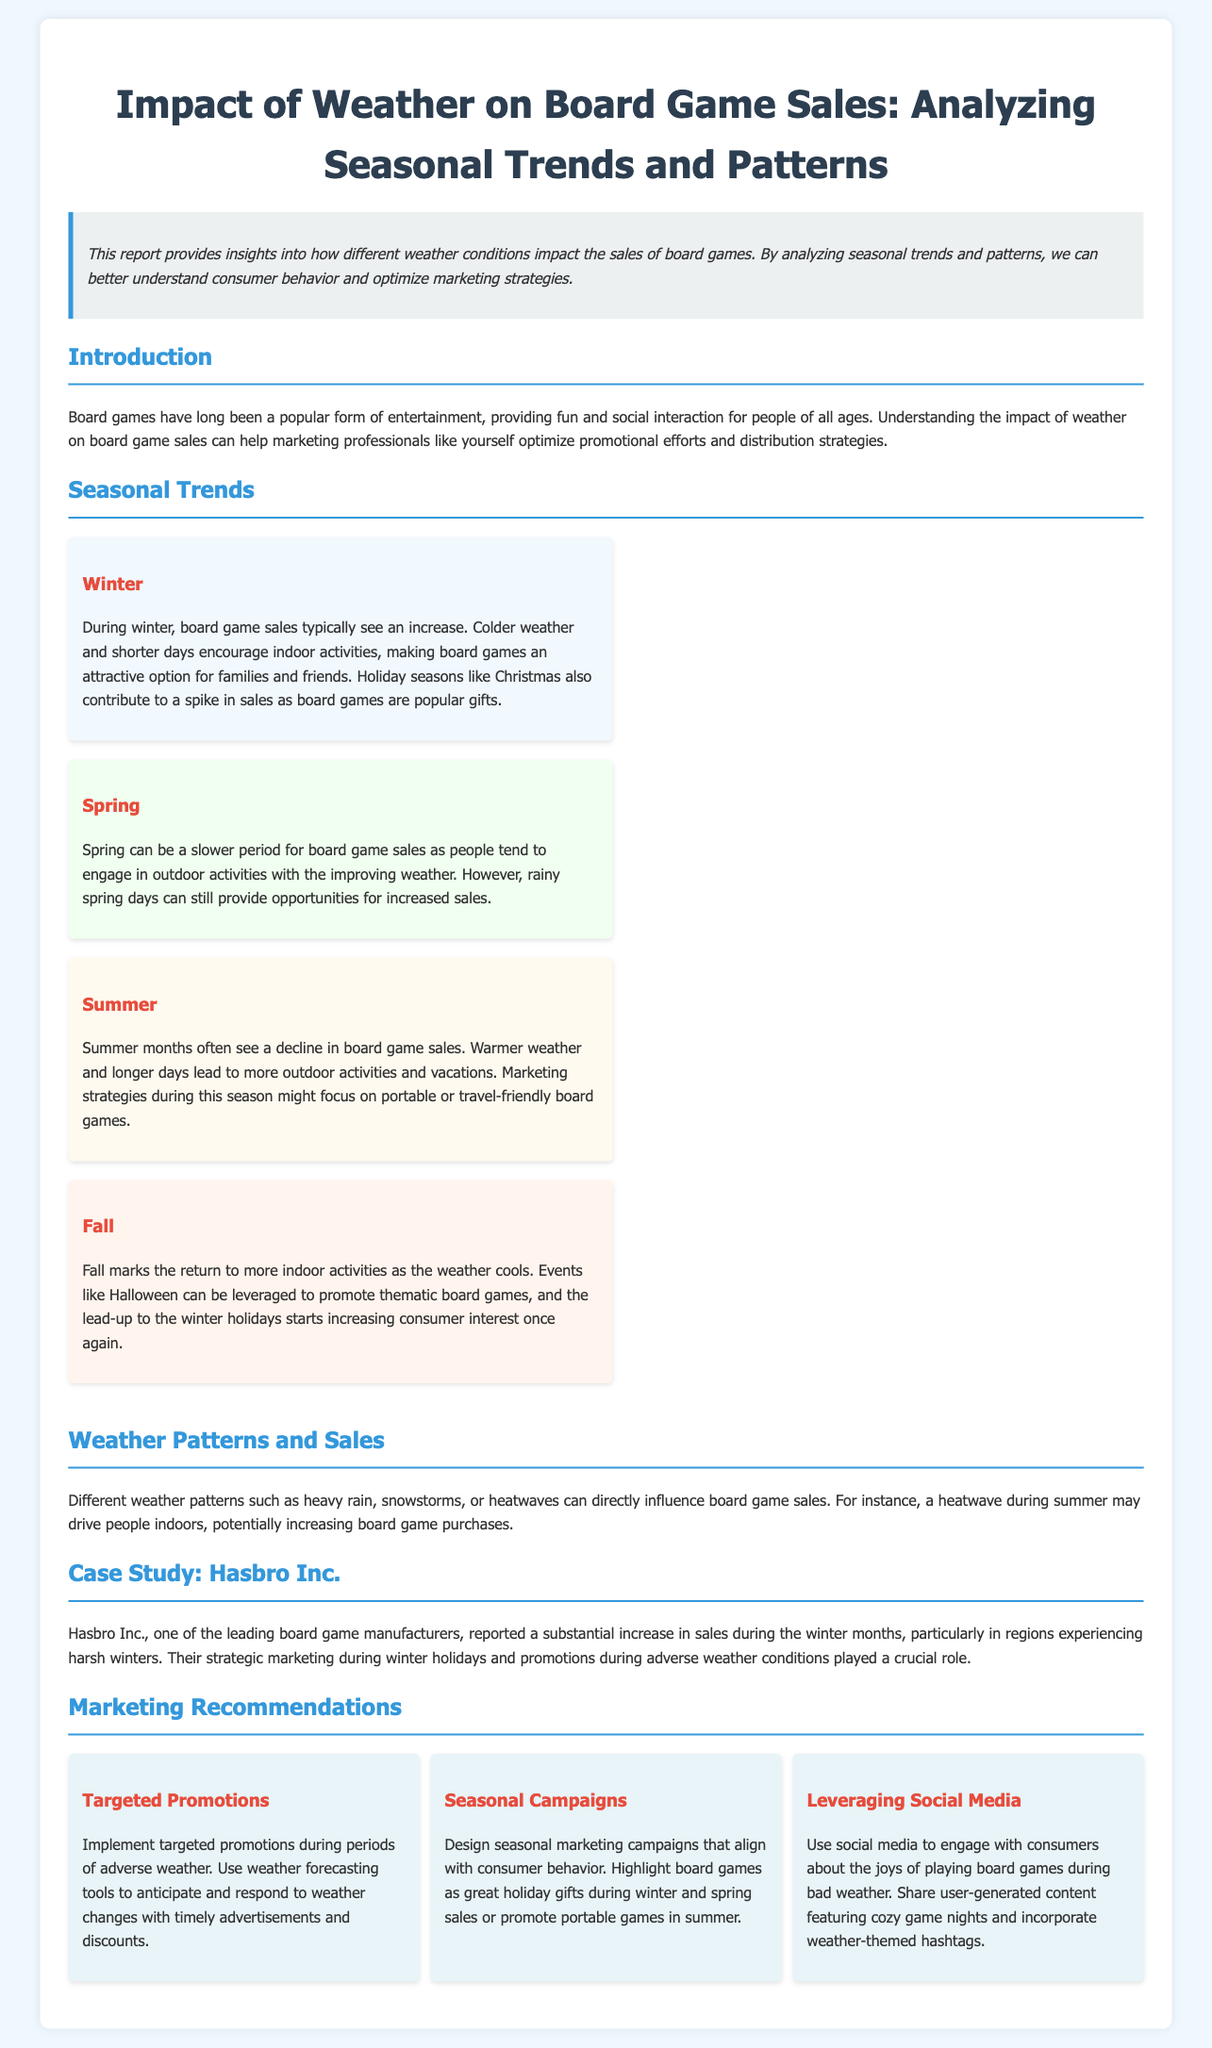What is the main focus of the report? The report focuses on how different weather conditions impact the sales of board games.
Answer: Impact of Weather on Board Game Sales What season typically sees an increase in board game sales? The report mentions that winter typically sees an increase in sales due to colder weather.
Answer: Winter What is a key marketing strategy during the spring? The report suggests that spring can be leveraged by promoting board games during rainy days.
Answer: Rainy days Which company reported increased sales during winter months? The case study mentions Hasbro Inc. as a company that reported substantial increases in sales.
Answer: Hasbro Inc What type of promotions are recommended during adverse weather? The report emphasizes implementing targeted promotions during periods of adverse weather.
Answer: Targeted promotions How do summer months typically affect board game sales? The document states that summer months often see a decline in board game sales due to more outdoor activities.
Answer: Decline What specific events can be leveraged for promotions in the fall? The report mentions that Halloween can be leveraged to promote thematic board games.
Answer: Halloween How does snow impact consumer behavior according to the report? The report notes that snowstorms can drive consumers indoors, potentially increasing board game purchases.
Answer: Increase What marketing approach involves social media engagement? The recommendations suggest using social media to engage with consumers about the joys of playing board games during bad weather.
Answer: Leveraging Social Media 